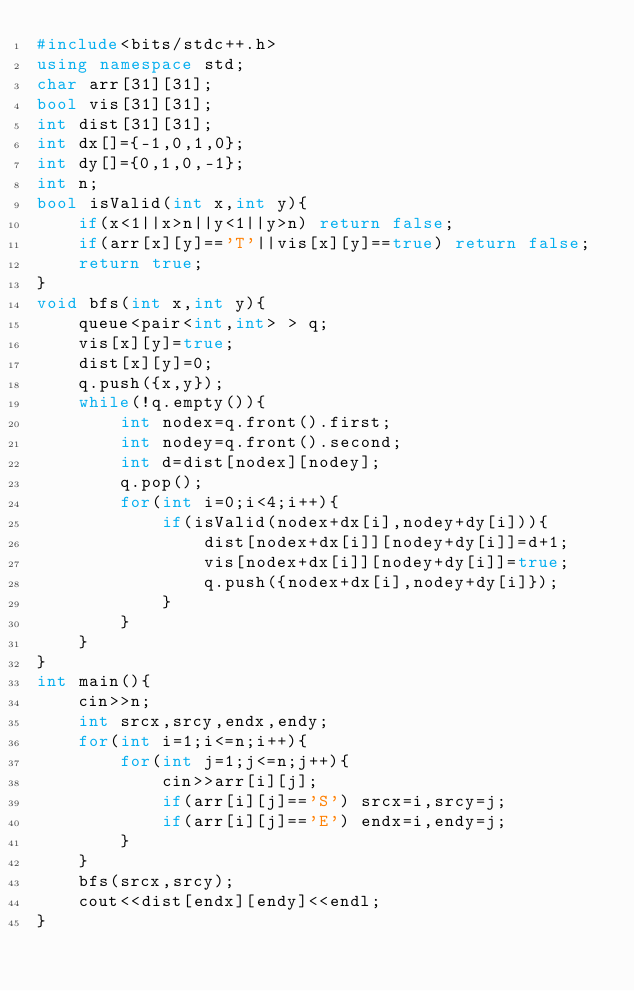Convert code to text. <code><loc_0><loc_0><loc_500><loc_500><_C++_>#include<bits/stdc++.h>
using namespace std;
char arr[31][31];
bool vis[31][31];
int dist[31][31];
int dx[]={-1,0,1,0};
int dy[]={0,1,0,-1};
int n;
bool isValid(int x,int y){
	if(x<1||x>n||y<1||y>n) return false;
	if(arr[x][y]=='T'||vis[x][y]==true) return false;
	return true;
}
void bfs(int x,int y){
	queue<pair<int,int> > q;
	vis[x][y]=true;
	dist[x][y]=0;
	q.push({x,y});
	while(!q.empty()){
		int nodex=q.front().first;
		int nodey=q.front().second;
		int d=dist[nodex][nodey];
		q.pop();
		for(int i=0;i<4;i++){
			if(isValid(nodex+dx[i],nodey+dy[i])){
				dist[nodex+dx[i]][nodey+dy[i]]=d+1;
				vis[nodex+dx[i]][nodey+dy[i]]=true;
				q.push({nodex+dx[i],nodey+dy[i]});
			}
		}
	}
}
int main(){
	cin>>n;
	int srcx,srcy,endx,endy;
	for(int i=1;i<=n;i++){
		for(int j=1;j<=n;j++){
			cin>>arr[i][j];
			if(arr[i][j]=='S') srcx=i,srcy=j;
			if(arr[i][j]=='E') endx=i,endy=j;
		}
	}
	bfs(srcx,srcy);
	cout<<dist[endx][endy]<<endl;
}
</code> 